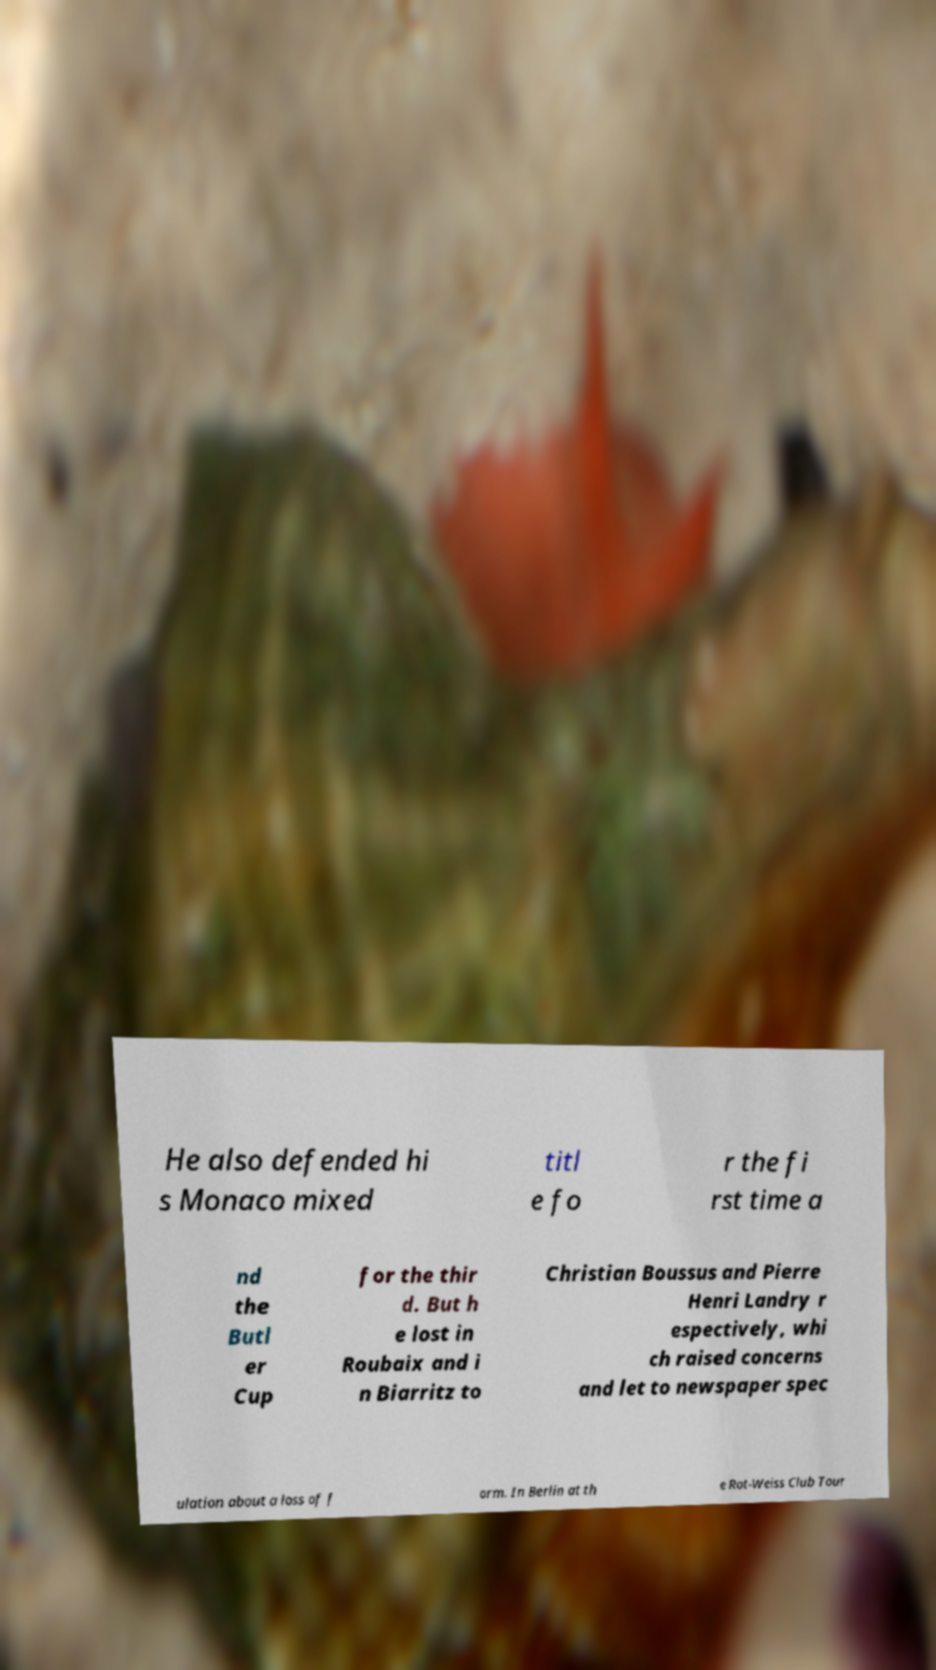I need the written content from this picture converted into text. Can you do that? He also defended hi s Monaco mixed titl e fo r the fi rst time a nd the Butl er Cup for the thir d. But h e lost in Roubaix and i n Biarritz to Christian Boussus and Pierre Henri Landry r espectively, whi ch raised concerns and let to newspaper spec ulation about a loss of f orm. In Berlin at th e Rot-Weiss Club Tour 